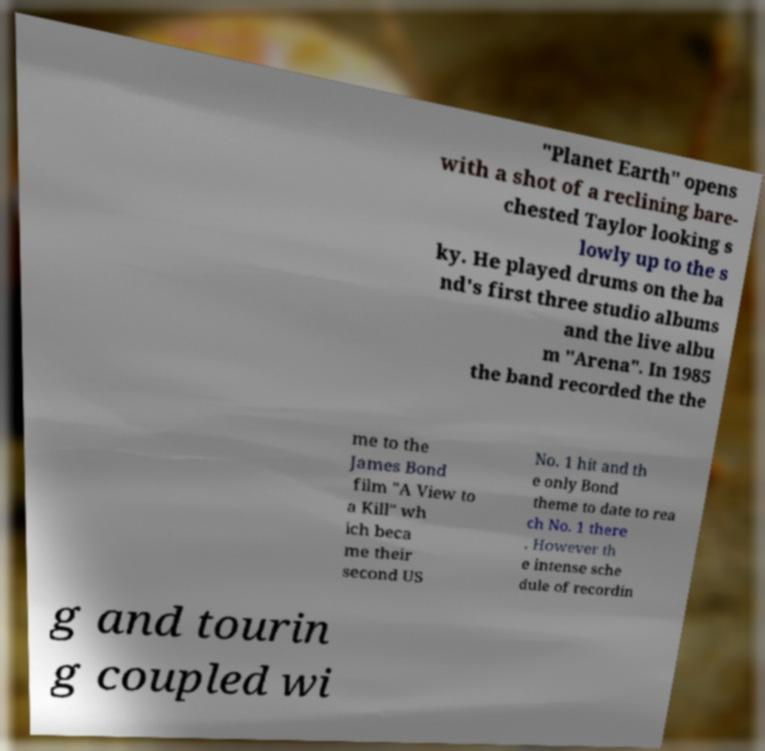Can you accurately transcribe the text from the provided image for me? "Planet Earth" opens with a shot of a reclining bare- chested Taylor looking s lowly up to the s ky. He played drums on the ba nd's first three studio albums and the live albu m "Arena". In 1985 the band recorded the the me to the James Bond film "A View to a Kill" wh ich beca me their second US No. 1 hit and th e only Bond theme to date to rea ch No. 1 there . However th e intense sche dule of recordin g and tourin g coupled wi 